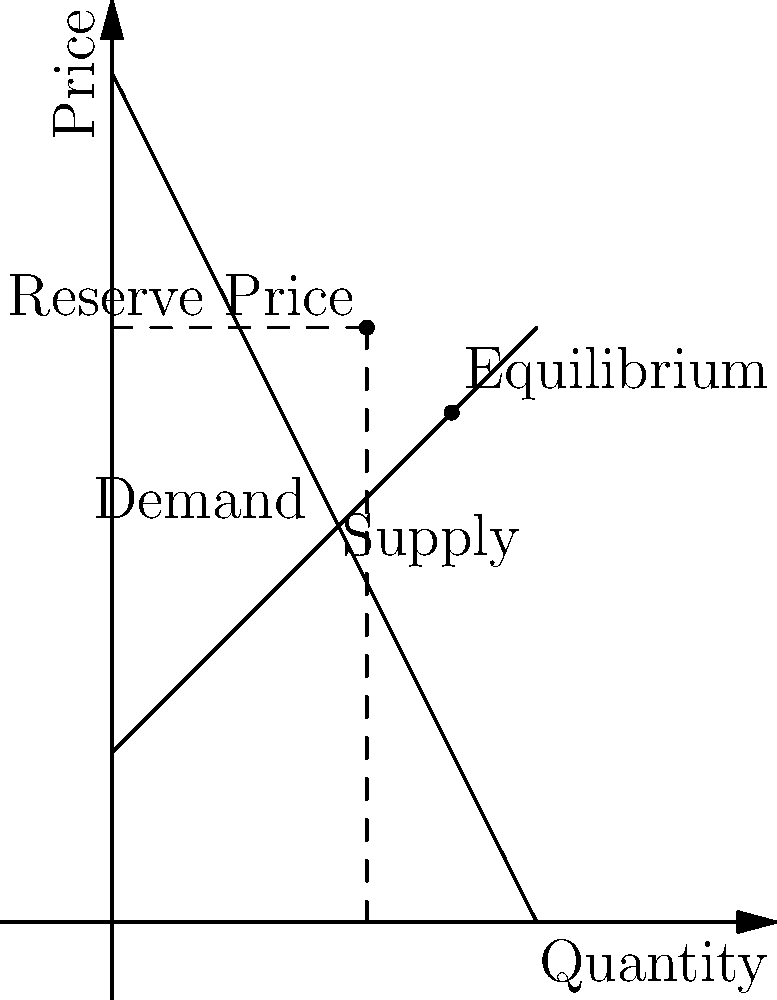As an auctioneer, you're trying to maximize revenue for a rare guitar once owned by a famous rock star. Given the supply and demand curves shown in the diagram, what is the optimal reserve price that would maximize your expected revenue? Assume that the demand function is $P = 100 - 2Q$ and the supply function is $P = 20 + Q$, where $P$ is price and $Q$ is quantity. To find the optimal reserve price, we'll follow these steps:

1) First, let's find the equilibrium point by equating supply and demand:
   $100 - 2Q = 20 + Q$
   $80 = 3Q$
   $Q = 80/3 ≈ 26.67$
   $P = 100 - 2(80/3) ≈ 46.67$

2) The optimal reserve price in this scenario is typically halfway between the equilibrium price and the price at which demand is zero (the y-intercept of the demand curve).

3) The y-intercept of the demand curve is at $P = 100$ (when $Q = 0$).

4) Therefore, the optimal reserve price is:
   $P_{reserve} = (100 + 46.67) / 2 = 73.335$

5) We can round this to $73.33$ for practical purposes.

This reserve price balances the risk of the item not selling (if set too high) with the potential for increased revenue (if set above the equilibrium price). It's designed to extract more surplus from high-value bidders while still maintaining a good chance of sale.
Answer: $73.33 